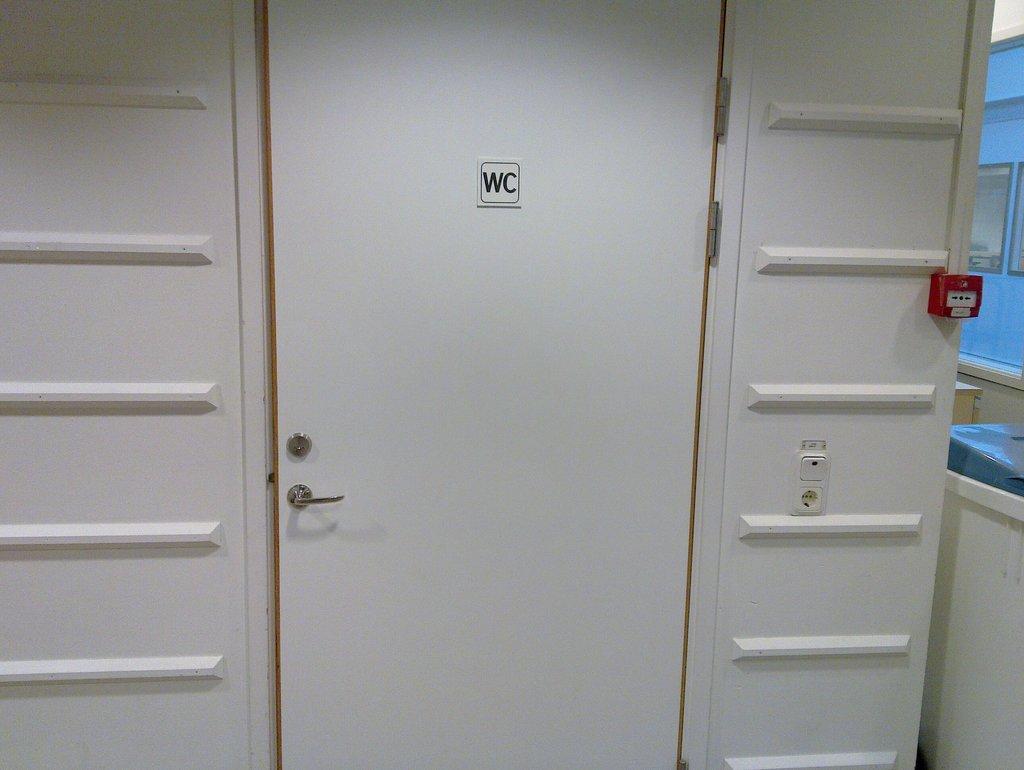Describe this image in one or two sentences. In this image we can see a door and fire alarm. 